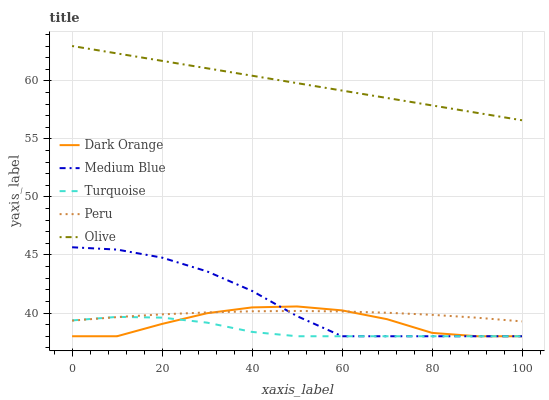Does Turquoise have the minimum area under the curve?
Answer yes or no. Yes. Does Olive have the maximum area under the curve?
Answer yes or no. Yes. Does Dark Orange have the minimum area under the curve?
Answer yes or no. No. Does Dark Orange have the maximum area under the curve?
Answer yes or no. No. Is Olive the smoothest?
Answer yes or no. Yes. Is Dark Orange the roughest?
Answer yes or no. Yes. Is Turquoise the smoothest?
Answer yes or no. No. Is Turquoise the roughest?
Answer yes or no. No. Does Peru have the lowest value?
Answer yes or no. No. Does Dark Orange have the highest value?
Answer yes or no. No. Is Dark Orange less than Olive?
Answer yes or no. Yes. Is Olive greater than Peru?
Answer yes or no. Yes. Does Dark Orange intersect Olive?
Answer yes or no. No. 